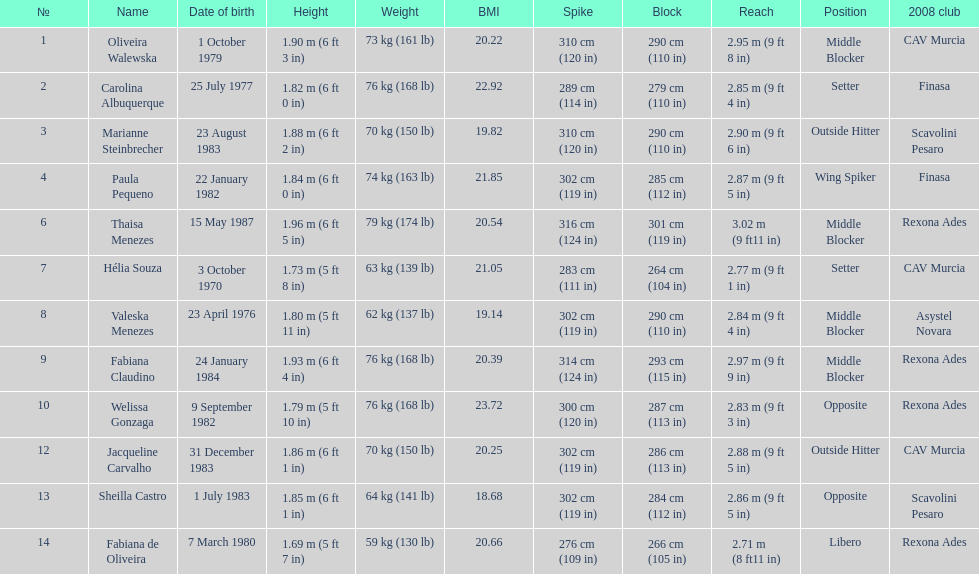Who is the next tallest player after thaisa menezes? Fabiana Claudino. 